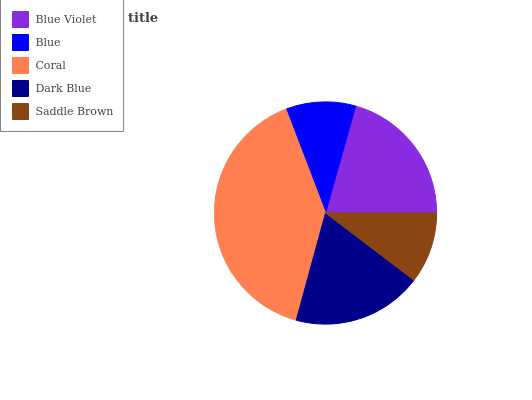Is Blue the minimum?
Answer yes or no. Yes. Is Coral the maximum?
Answer yes or no. Yes. Is Coral the minimum?
Answer yes or no. No. Is Blue the maximum?
Answer yes or no. No. Is Coral greater than Blue?
Answer yes or no. Yes. Is Blue less than Coral?
Answer yes or no. Yes. Is Blue greater than Coral?
Answer yes or no. No. Is Coral less than Blue?
Answer yes or no. No. Is Dark Blue the high median?
Answer yes or no. Yes. Is Dark Blue the low median?
Answer yes or no. Yes. Is Saddle Brown the high median?
Answer yes or no. No. Is Blue Violet the low median?
Answer yes or no. No. 